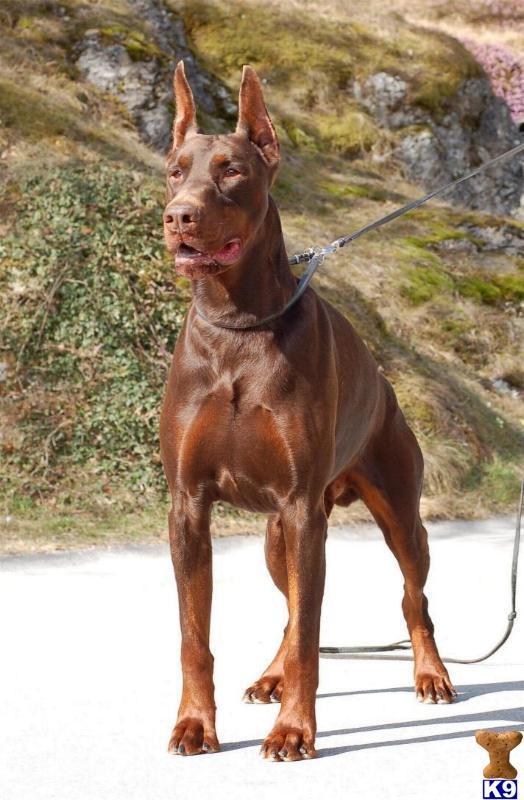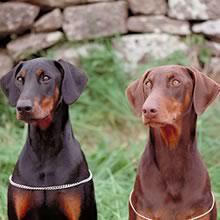The first image is the image on the left, the second image is the image on the right. Considering the images on both sides, is "There are exactly two dogs." valid? Answer yes or no. No. 